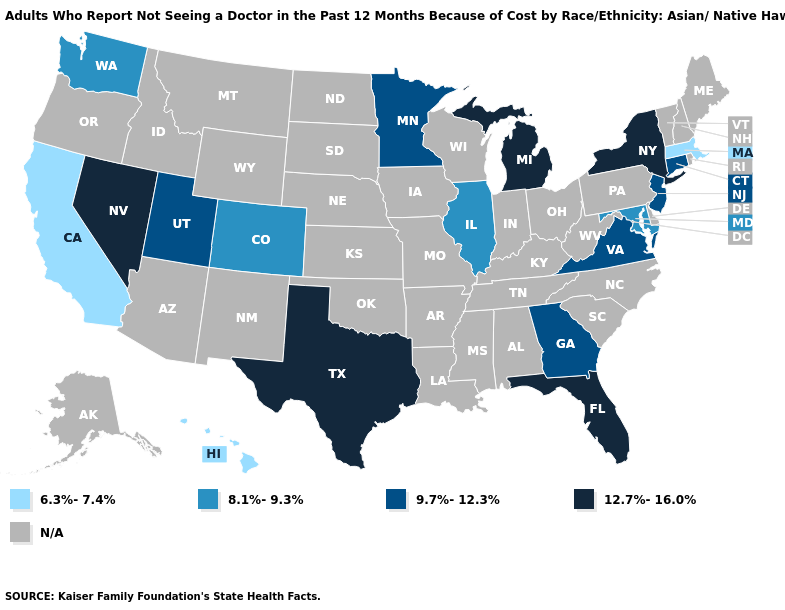Does Florida have the lowest value in the South?
Quick response, please. No. What is the value of Maine?
Keep it brief. N/A. Name the states that have a value in the range 12.7%-16.0%?
Be succinct. Florida, Michigan, Nevada, New York, Texas. What is the highest value in states that border Oklahoma?
Quick response, please. 12.7%-16.0%. Which states have the highest value in the USA?
Answer briefly. Florida, Michigan, Nevada, New York, Texas. What is the value of Alaska?
Concise answer only. N/A. Is the legend a continuous bar?
Be succinct. No. What is the lowest value in the MidWest?
Answer briefly. 8.1%-9.3%. What is the value of Maine?
Answer briefly. N/A. What is the lowest value in states that border Vermont?
Keep it brief. 6.3%-7.4%. Name the states that have a value in the range 8.1%-9.3%?
Answer briefly. Colorado, Illinois, Maryland, Washington. 